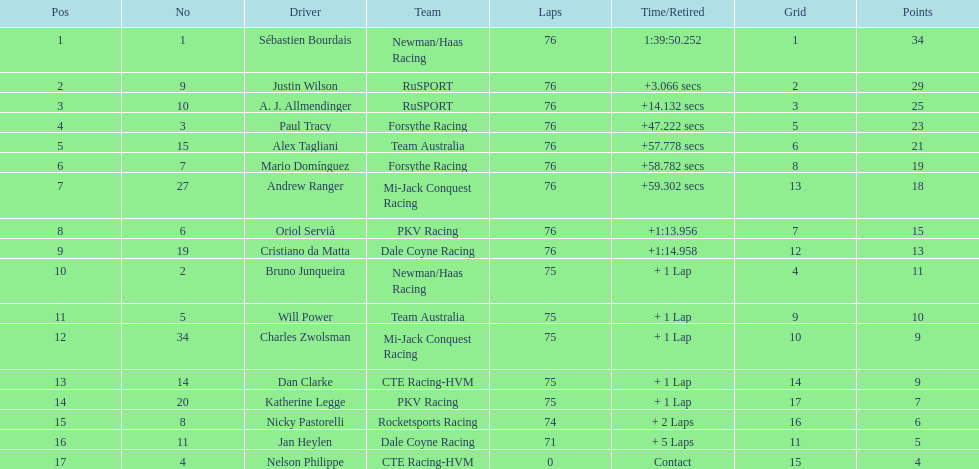Among drivers, who has the greatest points tally? Sebastien Bourdais. 